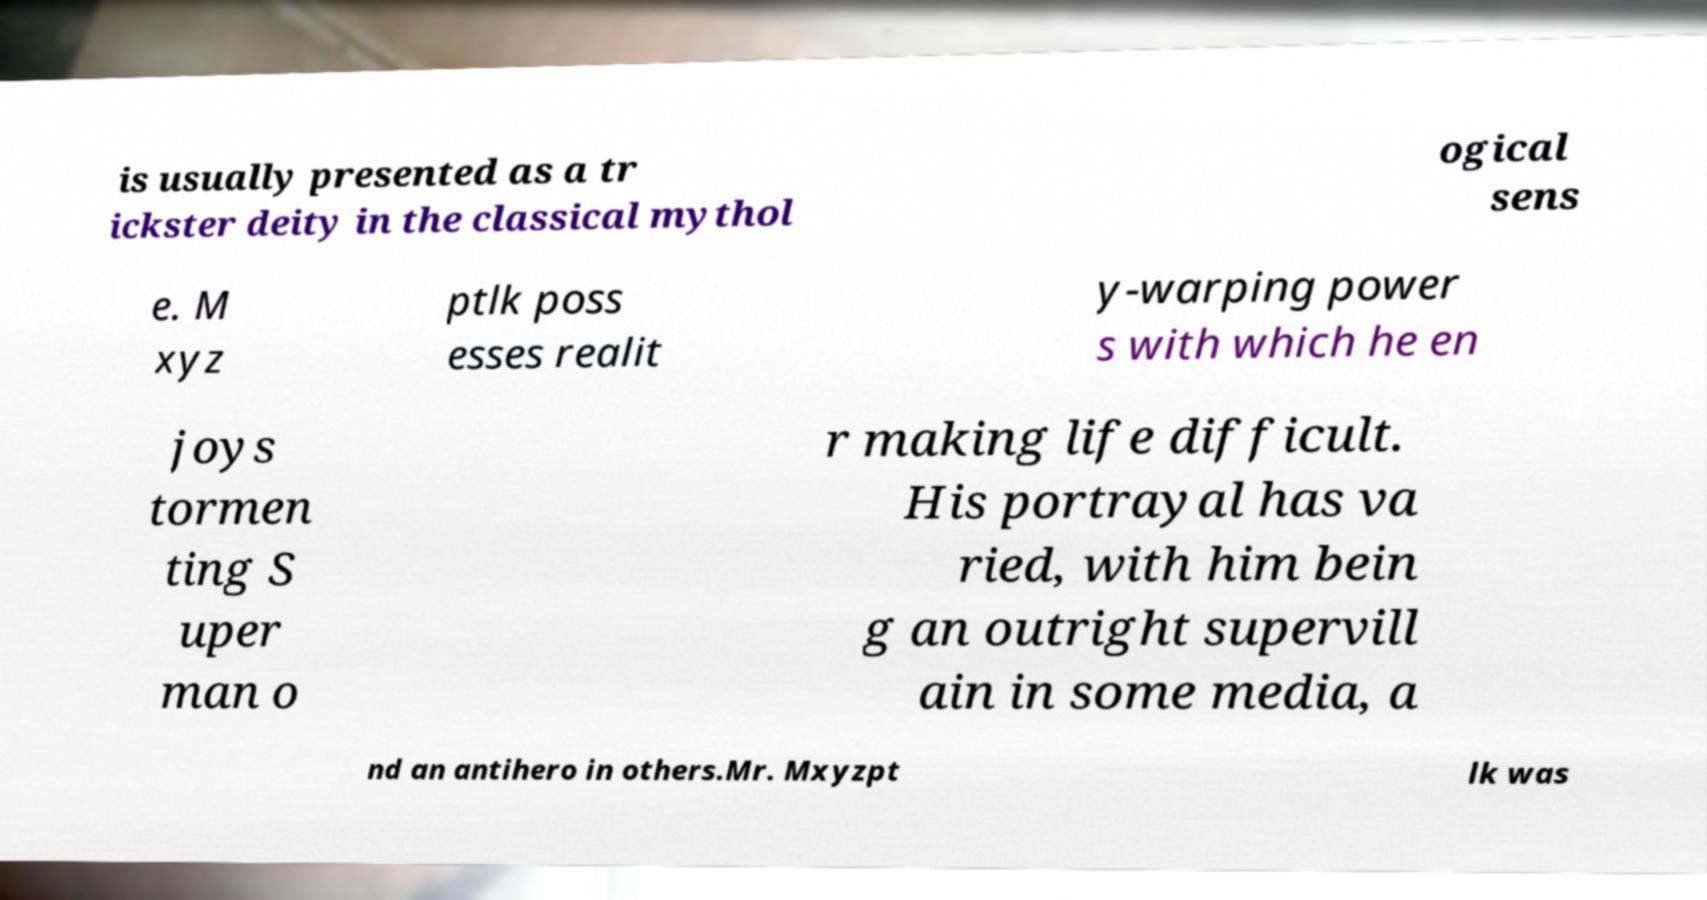Could you assist in decoding the text presented in this image and type it out clearly? is usually presented as a tr ickster deity in the classical mythol ogical sens e. M xyz ptlk poss esses realit y-warping power s with which he en joys tormen ting S uper man o r making life difficult. His portrayal has va ried, with him bein g an outright supervill ain in some media, a nd an antihero in others.Mr. Mxyzpt lk was 